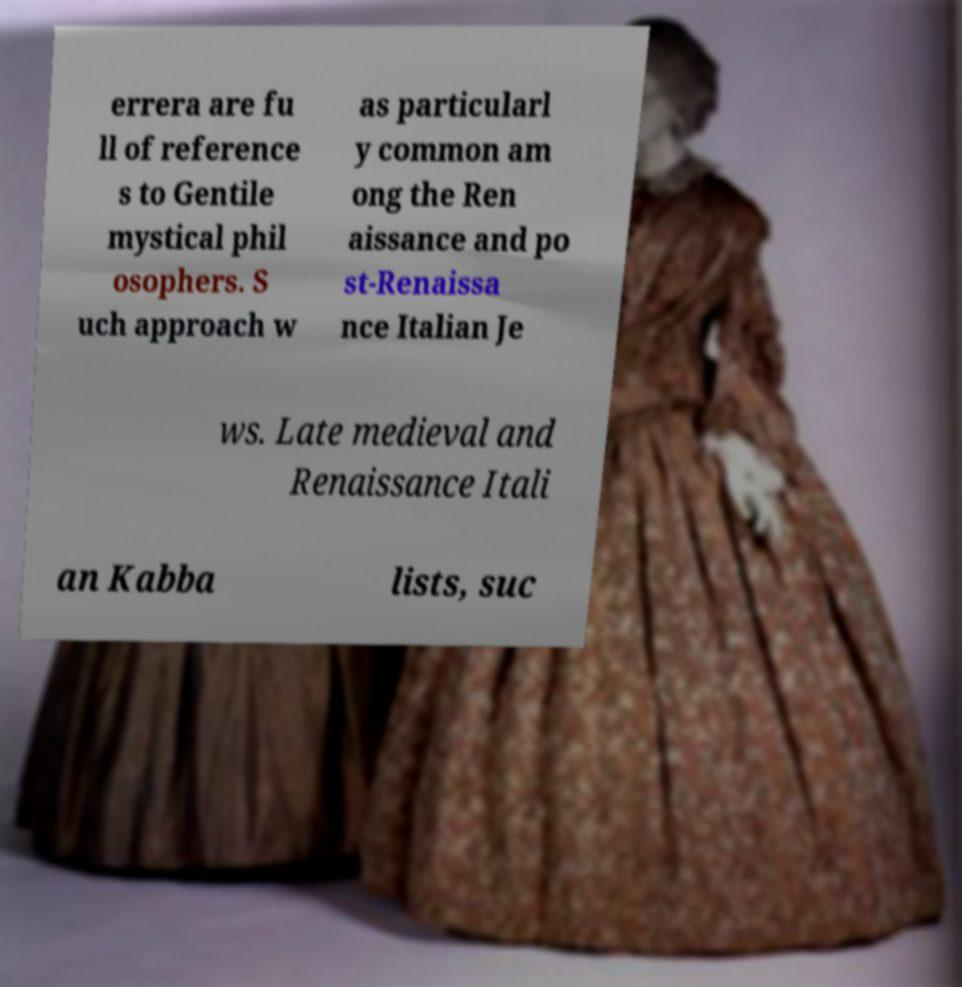Please identify and transcribe the text found in this image. errera are fu ll of reference s to Gentile mystical phil osophers. S uch approach w as particularl y common am ong the Ren aissance and po st-Renaissa nce Italian Je ws. Late medieval and Renaissance Itali an Kabba lists, suc 